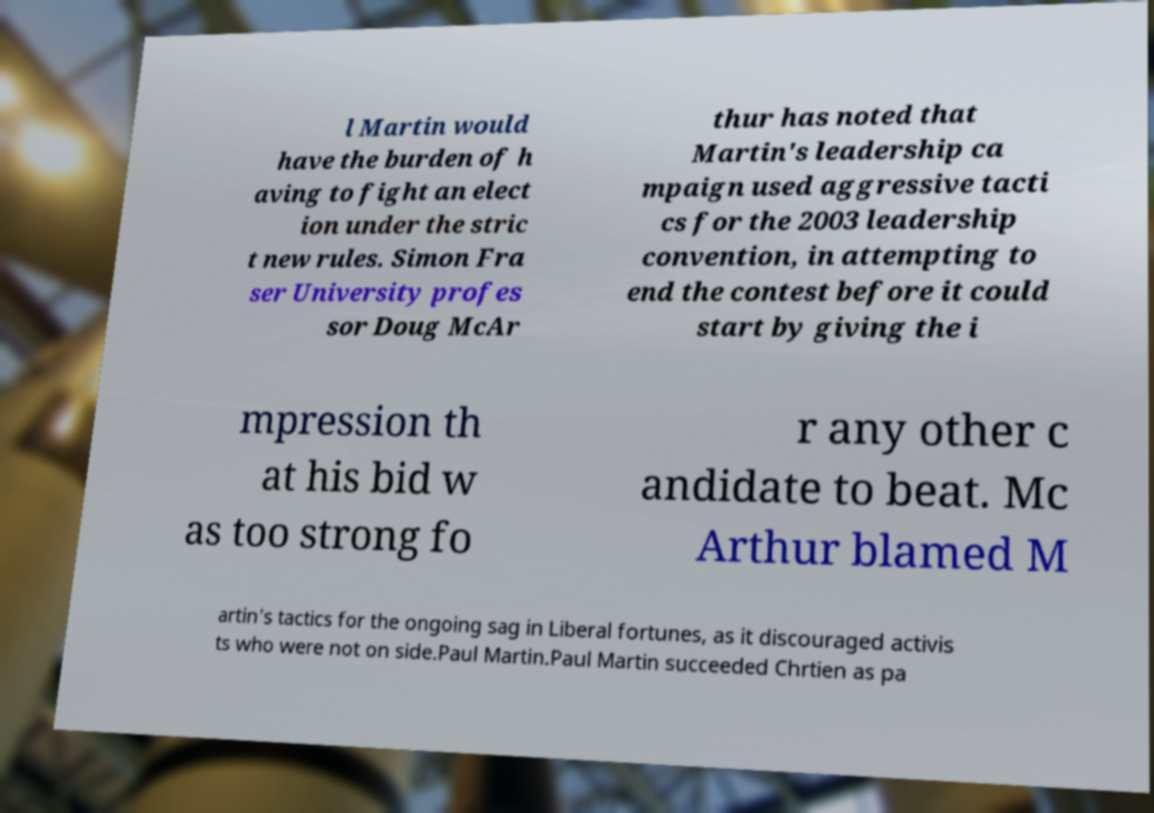I need the written content from this picture converted into text. Can you do that? l Martin would have the burden of h aving to fight an elect ion under the stric t new rules. Simon Fra ser University profes sor Doug McAr thur has noted that Martin's leadership ca mpaign used aggressive tacti cs for the 2003 leadership convention, in attempting to end the contest before it could start by giving the i mpression th at his bid w as too strong fo r any other c andidate to beat. Mc Arthur blamed M artin's tactics for the ongoing sag in Liberal fortunes, as it discouraged activis ts who were not on side.Paul Martin.Paul Martin succeeded Chrtien as pa 